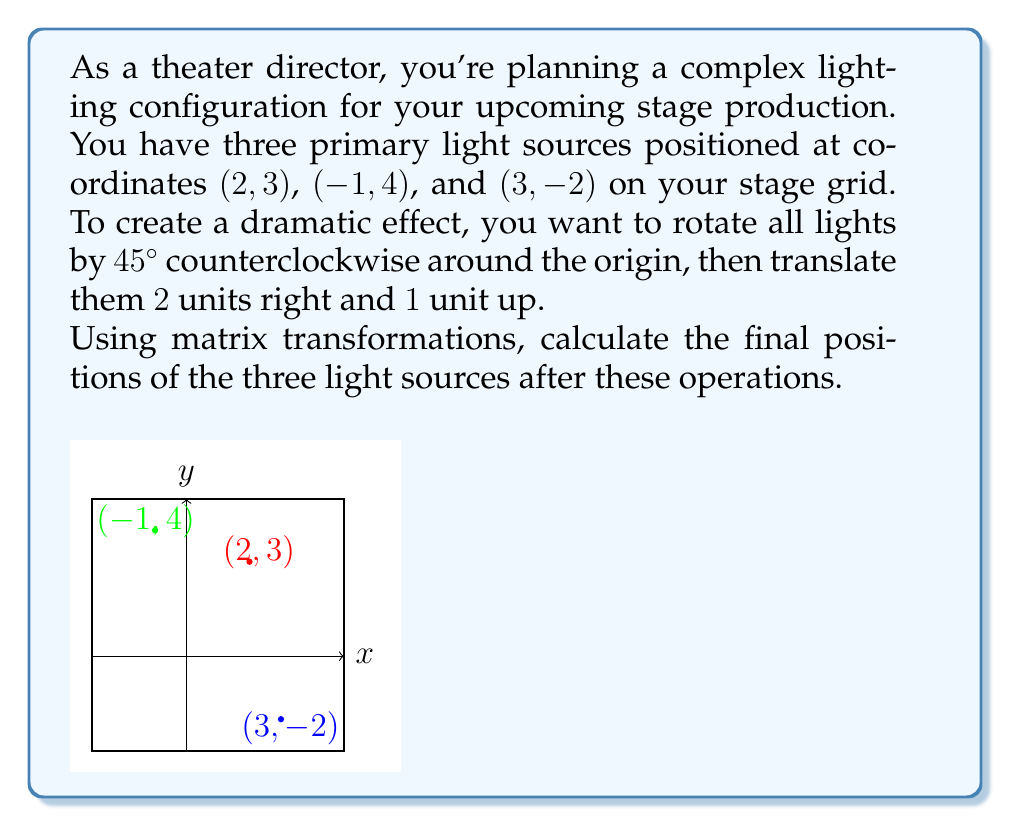Could you help me with this problem? Let's approach this step-by-step:

1) First, we need to set up our transformation matrices:

   Rotation matrix (45° counterclockwise):
   $$R = \begin{pmatrix} \cos 45° & -\sin 45° \\ \sin 45° & \cos 45° \end{pmatrix} = \begin{pmatrix} \frac{\sqrt{2}}{2} & -\frac{\sqrt{2}}{2} \\ \frac{\sqrt{2}}{2} & \frac{\sqrt{2}}{2} \end{pmatrix}$$

   Translation matrix:
   $$T = \begin{pmatrix} 2 \\ 1 \end{pmatrix}$$

2) We'll apply the rotation first, then the translation. For each point $(x, y)$, we'll compute:

   $$\begin{pmatrix} x' \\ y' \end{pmatrix} = R\begin{pmatrix} x \\ y \end{pmatrix} + T$$

3) Let's calculate for each point:

   For (2, 3):
   $$\begin{pmatrix} \frac{\sqrt{2}}{2} & -\frac{\sqrt{2}}{2} \\ \frac{\sqrt{2}}{2} & \frac{\sqrt{2}}{2} \end{pmatrix}\begin{pmatrix} 2 \\ 3 \end{pmatrix} + \begin{pmatrix} 2 \\ 1 \end{pmatrix}$$
   $$= \begin{pmatrix} 2\frac{\sqrt{2}}{2} - 3\frac{\sqrt{2}}{2} \\ 2\frac{\sqrt{2}}{2} + 3\frac{\sqrt{2}}{2} \end{pmatrix} + \begin{pmatrix} 2 \\ 1 \end{pmatrix}$$
   $$= \begin{pmatrix} -\frac{\sqrt{2}}{2} \\ 5\frac{\sqrt{2}}{2} \end{pmatrix} + \begin{pmatrix} 2 \\ 1 \end{pmatrix} = \begin{pmatrix} 2-\frac{\sqrt{2}}{2} \\ 1+5\frac{\sqrt{2}}{2} \end{pmatrix}$$

   For (-1, 4):
   $$\begin{pmatrix} \frac{\sqrt{2}}{2} & -\frac{\sqrt{2}}{2} \\ \frac{\sqrt{2}}{2} & \frac{\sqrt{2}}{2} \end{pmatrix}\begin{pmatrix} -1 \\ 4 \end{pmatrix} + \begin{pmatrix} 2 \\ 1 \end{pmatrix}$$
   $$= \begin{pmatrix} -\frac{\sqrt{2}}{2} - 4\frac{\sqrt{2}}{2} \\ -\frac{\sqrt{2}}{2} + 4\frac{\sqrt{2}}{2} \end{pmatrix} + \begin{pmatrix} 2 \\ 1 \end{pmatrix}$$
   $$= \begin{pmatrix} -5\frac{\sqrt{2}}{2} \\ 3\frac{\sqrt{2}}{2} \end{pmatrix} + \begin{pmatrix} 2 \\ 1 \end{pmatrix} = \begin{pmatrix} 2-5\frac{\sqrt{2}}{2} \\ 1+3\frac{\sqrt{2}}{2} \end{pmatrix}$$

   For (3, -2):
   $$\begin{pmatrix} \frac{\sqrt{2}}{2} & -\frac{\sqrt{2}}{2} \\ \frac{\sqrt{2}}{2} & \frac{\sqrt{2}}{2} \end{pmatrix}\begin{pmatrix} 3 \\ -2 \end{pmatrix} + \begin{pmatrix} 2 \\ 1 \end{pmatrix}$$
   $$= \begin{pmatrix} 3\frac{\sqrt{2}}{2} + 2\frac{\sqrt{2}}{2} \\ 3\frac{\sqrt{2}}{2} - 2\frac{\sqrt{2}}{2} \end{pmatrix} + \begin{pmatrix} 2 \\ 1 \end{pmatrix}$$
   $$= \begin{pmatrix} 5\frac{\sqrt{2}}{2} \\ \frac{\sqrt{2}}{2} \end{pmatrix} + \begin{pmatrix} 2 \\ 1 \end{pmatrix} = \begin{pmatrix} 2+5\frac{\sqrt{2}}{2} \\ 1+\frac{\sqrt{2}}{2} \end{pmatrix}$$
Answer: $\left(2-\frac{\sqrt{2}}{2}, 1+5\frac{\sqrt{2}}{2}\right)$, $\left(2-5\frac{\sqrt{2}}{2}, 1+3\frac{\sqrt{2}}{2}\right)$, $\left(2+5\frac{\sqrt{2}}{2}, 1+\frac{\sqrt{2}}{2}\right)$ 